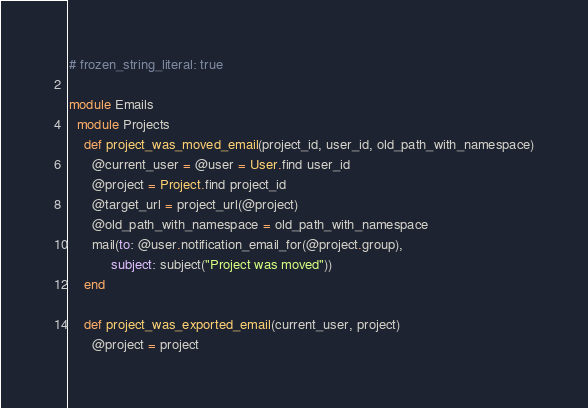Convert code to text. <code><loc_0><loc_0><loc_500><loc_500><_Ruby_># frozen_string_literal: true

module Emails
  module Projects
    def project_was_moved_email(project_id, user_id, old_path_with_namespace)
      @current_user = @user = User.find user_id
      @project = Project.find project_id
      @target_url = project_url(@project)
      @old_path_with_namespace = old_path_with_namespace
      mail(to: @user.notification_email_for(@project.group),
           subject: subject("Project was moved"))
    end

    def project_was_exported_email(current_user, project)
      @project = project</code> 